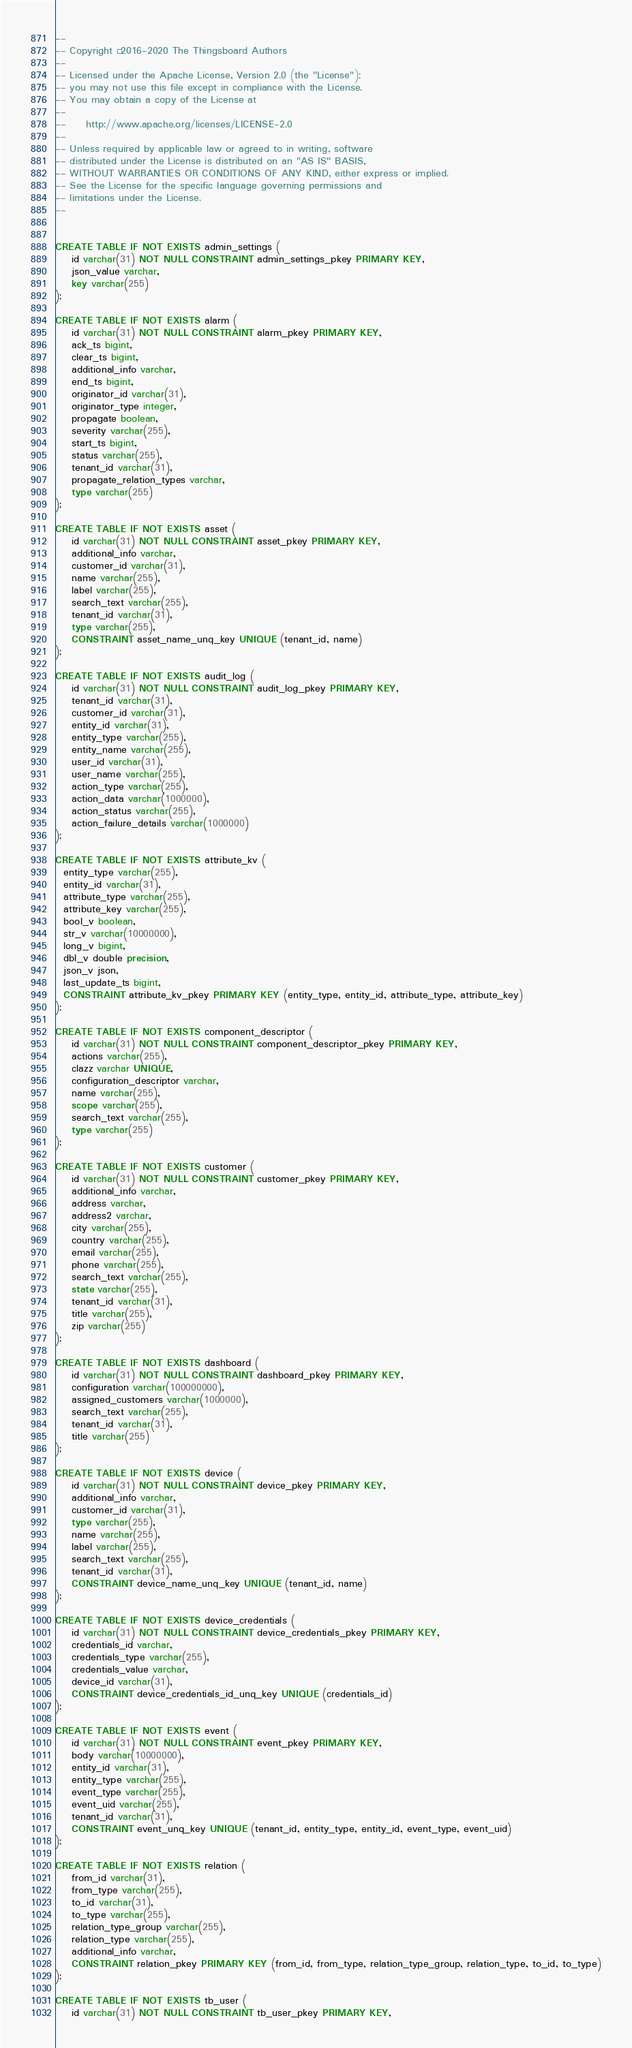Convert code to text. <code><loc_0><loc_0><loc_500><loc_500><_SQL_>--
-- Copyright © 2016-2020 The Thingsboard Authors
--
-- Licensed under the Apache License, Version 2.0 (the "License");
-- you may not use this file except in compliance with the License.
-- You may obtain a copy of the License at
--
--     http://www.apache.org/licenses/LICENSE-2.0
--
-- Unless required by applicable law or agreed to in writing, software
-- distributed under the License is distributed on an "AS IS" BASIS,
-- WITHOUT WARRANTIES OR CONDITIONS OF ANY KIND, either express or implied.
-- See the License for the specific language governing permissions and
-- limitations under the License.
--


CREATE TABLE IF NOT EXISTS admin_settings (
    id varchar(31) NOT NULL CONSTRAINT admin_settings_pkey PRIMARY KEY,
    json_value varchar,
    key varchar(255)
);

CREATE TABLE IF NOT EXISTS alarm (
    id varchar(31) NOT NULL CONSTRAINT alarm_pkey PRIMARY KEY,
    ack_ts bigint,
    clear_ts bigint,
    additional_info varchar,
    end_ts bigint,
    originator_id varchar(31),
    originator_type integer,
    propagate boolean,
    severity varchar(255),
    start_ts bigint,
    status varchar(255),
    tenant_id varchar(31),
    propagate_relation_types varchar,
    type varchar(255)
);

CREATE TABLE IF NOT EXISTS asset (
    id varchar(31) NOT NULL CONSTRAINT asset_pkey PRIMARY KEY,
    additional_info varchar,
    customer_id varchar(31),
    name varchar(255),
    label varchar(255),
    search_text varchar(255),
    tenant_id varchar(31),
    type varchar(255),
    CONSTRAINT asset_name_unq_key UNIQUE (tenant_id, name)
);

CREATE TABLE IF NOT EXISTS audit_log (
    id varchar(31) NOT NULL CONSTRAINT audit_log_pkey PRIMARY KEY,
    tenant_id varchar(31),
    customer_id varchar(31),
    entity_id varchar(31),
    entity_type varchar(255),
    entity_name varchar(255),
    user_id varchar(31),
    user_name varchar(255),
    action_type varchar(255),
    action_data varchar(1000000),
    action_status varchar(255),
    action_failure_details varchar(1000000)
);

CREATE TABLE IF NOT EXISTS attribute_kv (
  entity_type varchar(255),
  entity_id varchar(31),
  attribute_type varchar(255),
  attribute_key varchar(255),
  bool_v boolean,
  str_v varchar(10000000),
  long_v bigint,
  dbl_v double precision,
  json_v json,
  last_update_ts bigint,
  CONSTRAINT attribute_kv_pkey PRIMARY KEY (entity_type, entity_id, attribute_type, attribute_key)
);

CREATE TABLE IF NOT EXISTS component_descriptor (
    id varchar(31) NOT NULL CONSTRAINT component_descriptor_pkey PRIMARY KEY,
    actions varchar(255),
    clazz varchar UNIQUE,
    configuration_descriptor varchar,
    name varchar(255),
    scope varchar(255),
    search_text varchar(255),
    type varchar(255)
);

CREATE TABLE IF NOT EXISTS customer (
    id varchar(31) NOT NULL CONSTRAINT customer_pkey PRIMARY KEY,
    additional_info varchar,
    address varchar,
    address2 varchar,
    city varchar(255),
    country varchar(255),
    email varchar(255),
    phone varchar(255),
    search_text varchar(255),
    state varchar(255),
    tenant_id varchar(31),
    title varchar(255),
    zip varchar(255)
);

CREATE TABLE IF NOT EXISTS dashboard (
    id varchar(31) NOT NULL CONSTRAINT dashboard_pkey PRIMARY KEY,
    configuration varchar(100000000),
    assigned_customers varchar(1000000),
    search_text varchar(255),
    tenant_id varchar(31),
    title varchar(255)
);

CREATE TABLE IF NOT EXISTS device (
    id varchar(31) NOT NULL CONSTRAINT device_pkey PRIMARY KEY,
    additional_info varchar,
    customer_id varchar(31),
    type varchar(255),
    name varchar(255),
    label varchar(255),
    search_text varchar(255),
    tenant_id varchar(31),
    CONSTRAINT device_name_unq_key UNIQUE (tenant_id, name)
);

CREATE TABLE IF NOT EXISTS device_credentials (
    id varchar(31) NOT NULL CONSTRAINT device_credentials_pkey PRIMARY KEY,
    credentials_id varchar,
    credentials_type varchar(255),
    credentials_value varchar,
    device_id varchar(31),
    CONSTRAINT device_credentials_id_unq_key UNIQUE (credentials_id)
);

CREATE TABLE IF NOT EXISTS event (
    id varchar(31) NOT NULL CONSTRAINT event_pkey PRIMARY KEY,
    body varchar(10000000),
    entity_id varchar(31),
    entity_type varchar(255),
    event_type varchar(255),
    event_uid varchar(255),
    tenant_id varchar(31),
    CONSTRAINT event_unq_key UNIQUE (tenant_id, entity_type, entity_id, event_type, event_uid)
);

CREATE TABLE IF NOT EXISTS relation (
    from_id varchar(31),
    from_type varchar(255),
    to_id varchar(31),
    to_type varchar(255),
    relation_type_group varchar(255),
    relation_type varchar(255),
    additional_info varchar,
    CONSTRAINT relation_pkey PRIMARY KEY (from_id, from_type, relation_type_group, relation_type, to_id, to_type)
);

CREATE TABLE IF NOT EXISTS tb_user (
    id varchar(31) NOT NULL CONSTRAINT tb_user_pkey PRIMARY KEY,</code> 